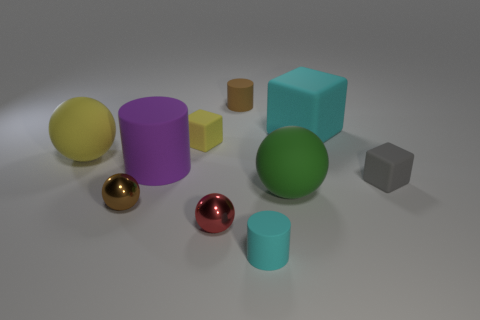How many spheres are in front of the big yellow rubber thing?
Your response must be concise. 3. How many tiny objects are either yellow matte objects or matte cubes?
Offer a very short reply. 2. What shape is the small brown metallic object in front of the gray rubber cube?
Offer a very short reply. Sphere. Are there any things that have the same color as the large rubber cube?
Keep it short and to the point. Yes. Do the cyan rubber object behind the gray object and the block in front of the small yellow rubber thing have the same size?
Your response must be concise. No. Is the number of yellow matte objects that are on the left side of the gray object greater than the number of small rubber blocks that are behind the big matte cylinder?
Provide a succinct answer. Yes. Are there any tiny brown cylinders that have the same material as the tiny yellow block?
Provide a succinct answer. Yes. Is the big cylinder the same color as the big block?
Your response must be concise. No. What is the sphere that is both in front of the large green thing and on the right side of the purple object made of?
Keep it short and to the point. Metal. What is the color of the big rubber cylinder?
Provide a short and direct response. Purple. 